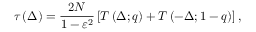Convert formula to latex. <formula><loc_0><loc_0><loc_500><loc_500>\tau \left ( \Delta \right ) = \frac { 2 N } { { 1 - \varepsilon ^ { 2 } } } \left [ T \left ( \Delta ; q \right ) + T \left ( - \Delta ; 1 - q \right ) \right ] ,</formula> 